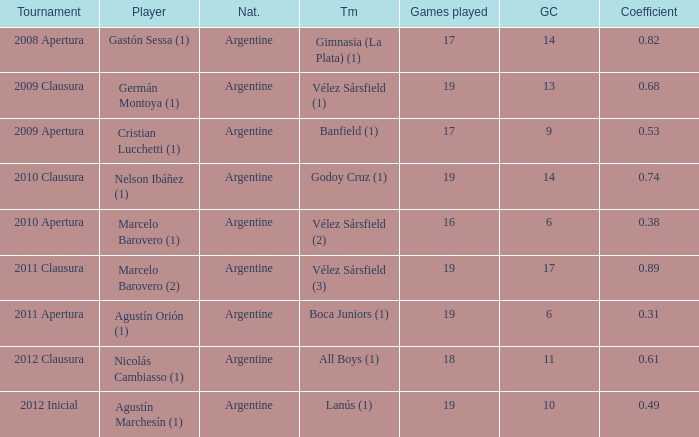How many nationalities are there for the 2011 apertura? 1.0. 